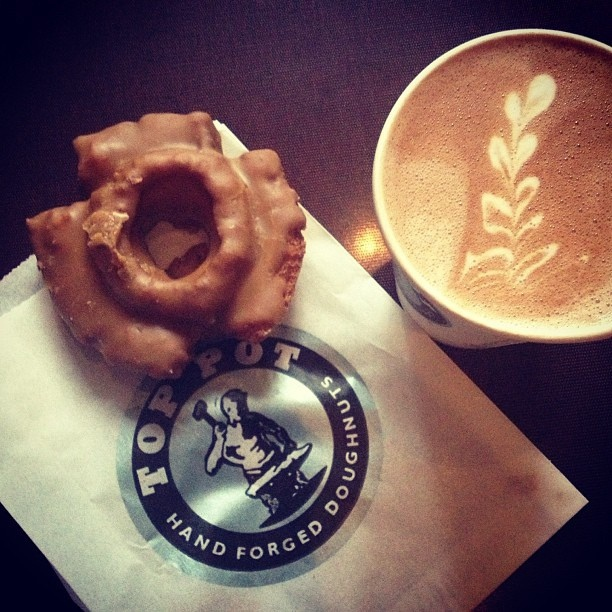Describe the objects in this image and their specific colors. I can see dining table in black and purple tones, cup in black, tan, khaki, brown, and maroon tones, donut in black, maroon, brown, tan, and purple tones, and dining table in black, darkgray, navy, and gray tones in this image. 